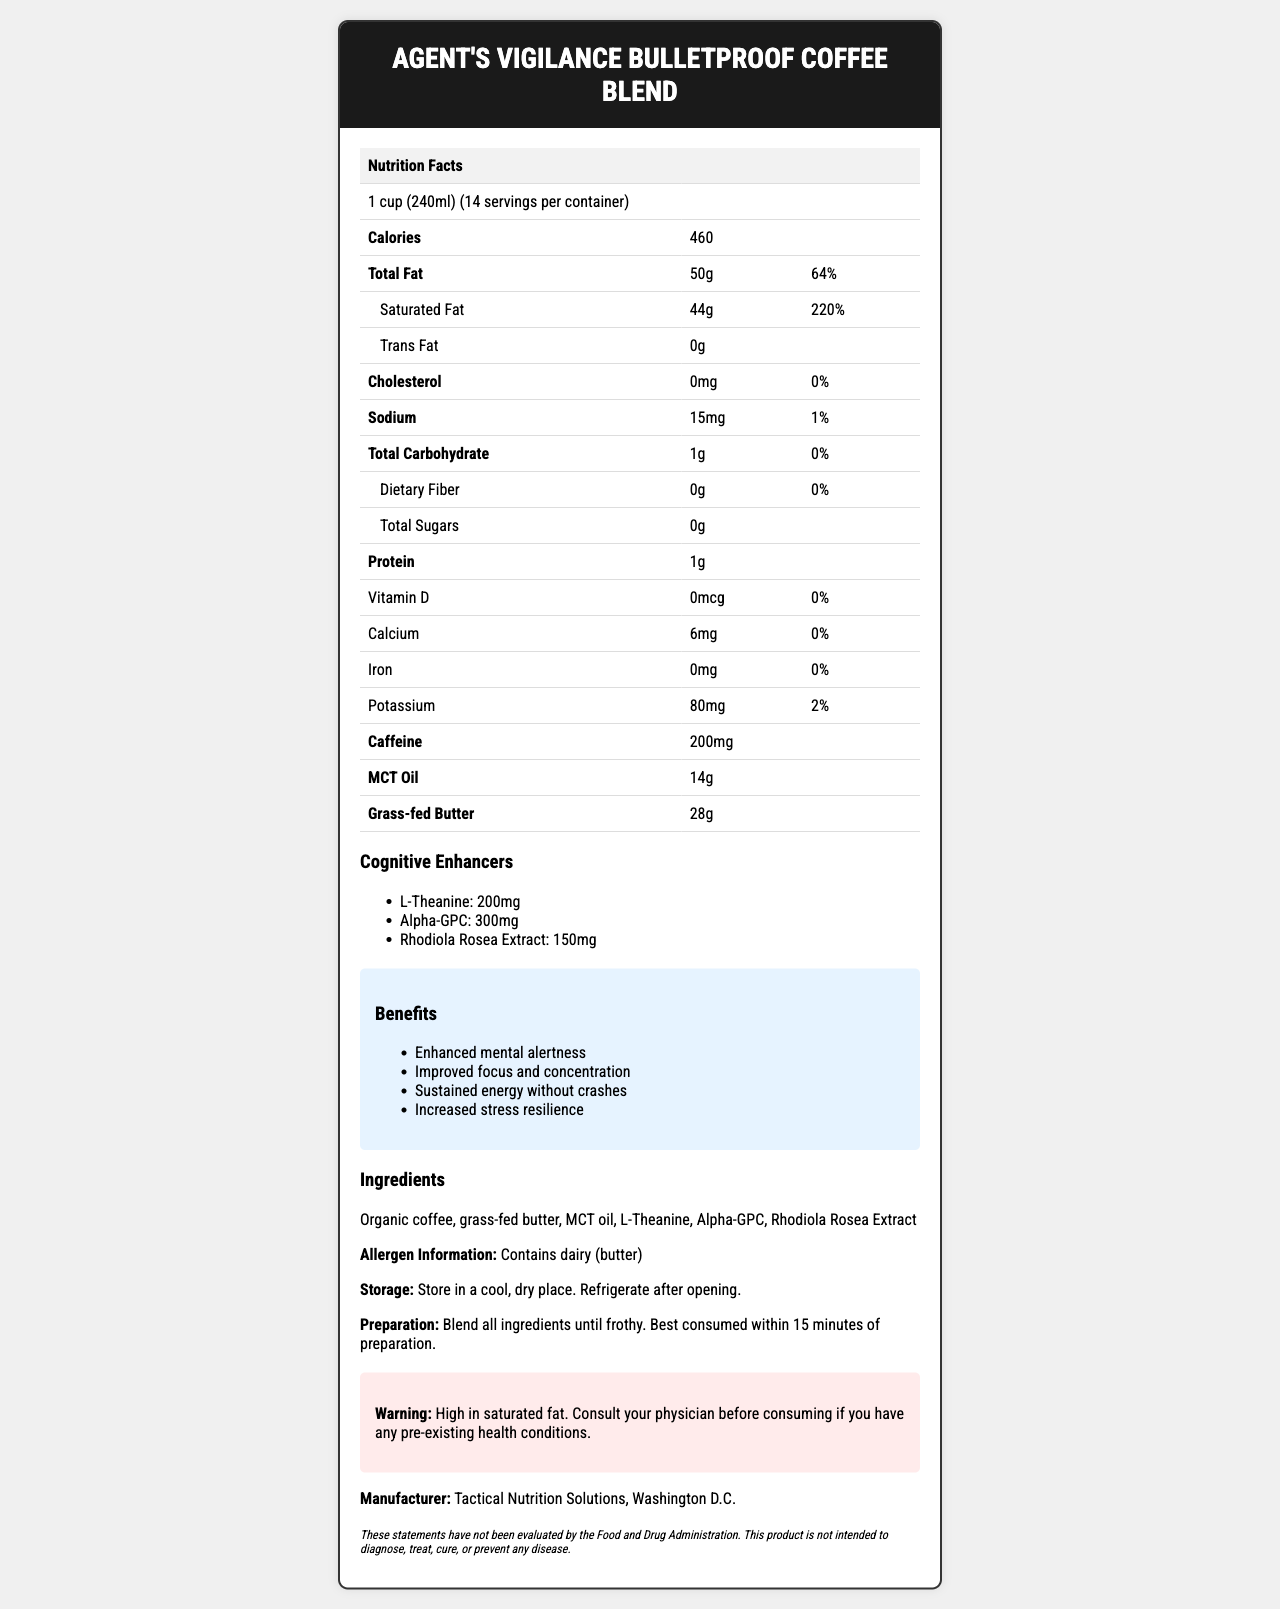what is the serving size of the Agent's Vigilance Bulletproof Coffee Blend? The serving size is clearly mentioned at the top of the Nutrition Facts as "1 cup (240ml)".
Answer: 1 cup (240ml) how many calories are in one serving? The number of calories per serving is listed as 460 in the Nutrition Facts section.
Answer: 460 calories what is the total fat content per serving, and what percentage of daily value does it represent? The Nutrition Facts label lists 50g of total fat per serving, which is 64% of the daily value.
Answer: 50g, 64% how much saturated fat does one serving contain? The Nutrition Facts section shows that each serving contains 44g of saturated fat.
Answer: 44g how much caffeine is in one serving? The amount of caffeine per serving is specified as 200mg in the label.
Answer: 200mg What are the cognitive enhancers included in this product? The label lists these cognitive enhancers: L-Theanine (200mg), Alpha-GPC (300mg), Rhodiola Rosea Extract (150mg).
Answer: L-Theanine, Alpha-GPC, Rhodiola Rosea Extract What benefits does this product offer? A. Improved digestion B. Enhanced mental alertness C. Weight loss D. Reduced inflammation The benefits section includes Enhanced mental alertness, Improved focus and concentration, Sustained energy without crashes, Increased stress resilience. "Enhanced mental alertness" is the correct option.
Answer: B. Enhanced mental alertness Which ingredient is NOT listed in the Agent's Vigilance Bulletproof Coffee Blend? A. Organic coffee B. MCT oil C. Cinnamon D. Grass-fed butter The listed ingredients are Organic coffee, grass-fed butter, MCT oil, L-Theanine, Alpha-GPC, Rhodiola Rosea Extract. Cinnamon is not mentioned.
Answer: C. Cinnamon Does this product contain any allergens? The allergen info specifies that the product contains dairy (butter).
Answer: Yes Does the product have any warnings associated with its consumption? There is a warning that indicates the product is high in saturated fat and advises consulting a physician if you have any pre-existing health conditions.
Answer: Yes Summarize the main idea of this document. The document comprehensively outlines the nutritional profile and ingredients of the bulletproof coffee blend, emphasizing its cognitive enhancement properties and associated health benefits.
Answer: The document provides detailed nutrition information about Agent's Vigilance Bulletproof Coffee Blend. It includes data on serving size, calories, macronutrients, caffeine, and cognitive enhancers present in the product. The label highlights the benefits, ingredients, allergen information, storage, and preparation instructions. It also contains a warning for people with health conditions and an FDA statement. What is the exact amount of vitamin D in the product? The Nutrition Facts section specifies that the amount of vitamin D is 0mcg.
Answer: 0mcg What company manufactures Agent's Vigilance Bulletproof Coffee Blend? The manufacturer's information is provided at the end of the document, listing Tactical Nutrition Solutions in Washington D.C. as the producer.
Answer: Tactical Nutrition Solutions, Washington D.C. What is the total carbohydrate content in one serving, and how does it compare to the daily value? The Nutrition Facts label lists the total carbohydrate content as 1g per serving, which is 0% of the daily value.
Answer: 1g, 0% Does the product help in weight loss? The document does not provide any information regarding weight loss benefits.
Answer: Cannot be determined How should the product be stored after opening? The storage instructions specify to keep the product in a cool, dry place and refrigerate after opening.
Answer: Refrigerate after opening 